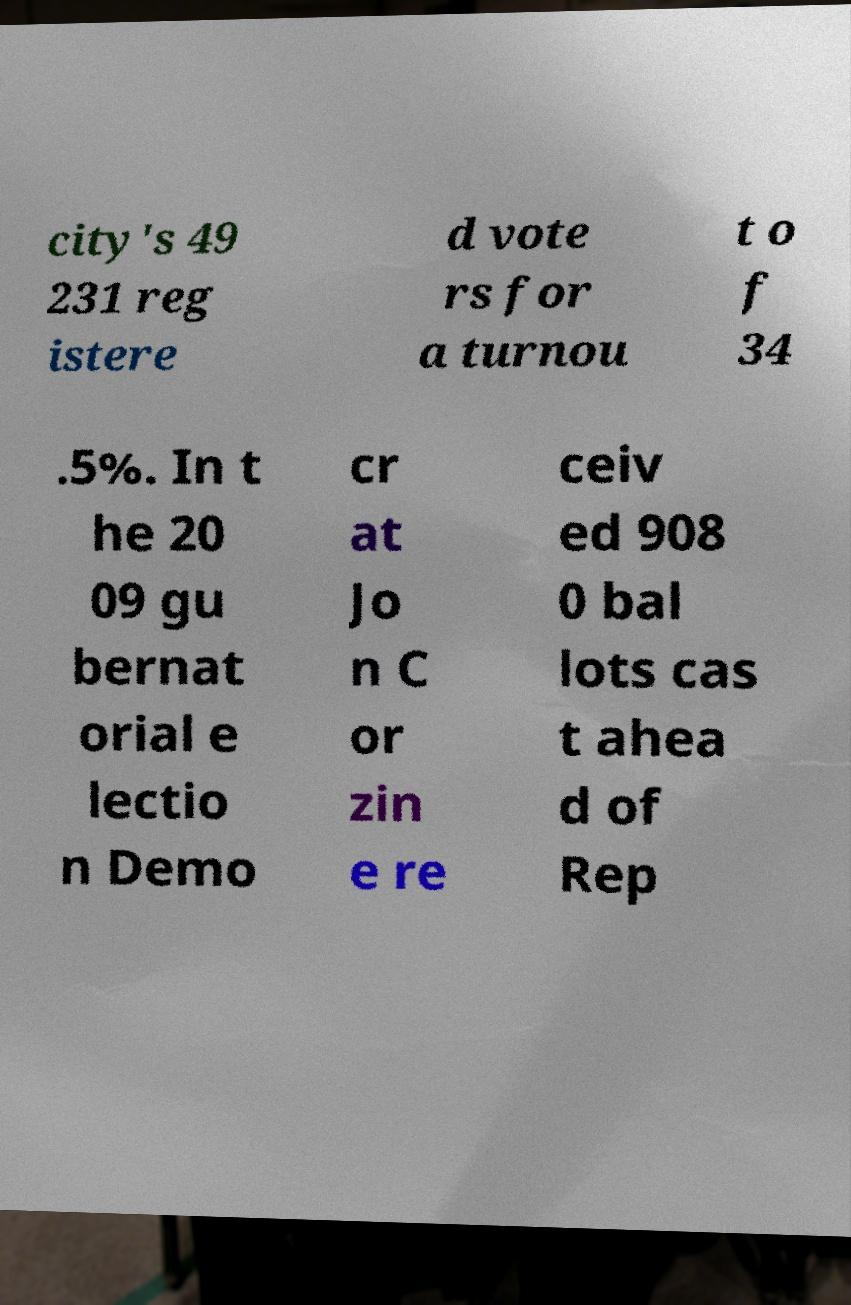Can you accurately transcribe the text from the provided image for me? city's 49 231 reg istere d vote rs for a turnou t o f 34 .5%. In t he 20 09 gu bernat orial e lectio n Demo cr at Jo n C or zin e re ceiv ed 908 0 bal lots cas t ahea d of Rep 